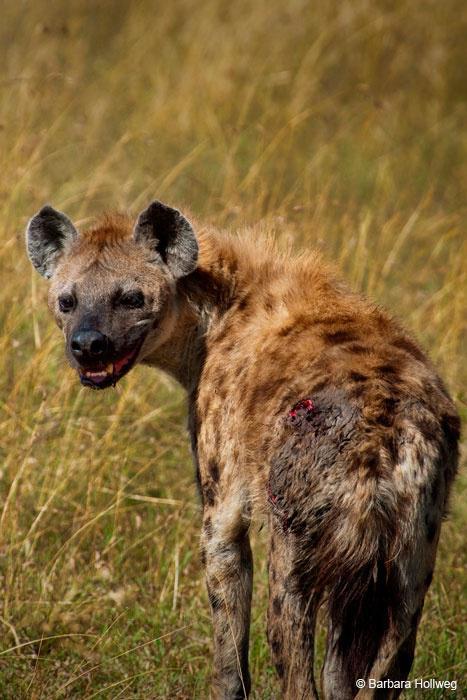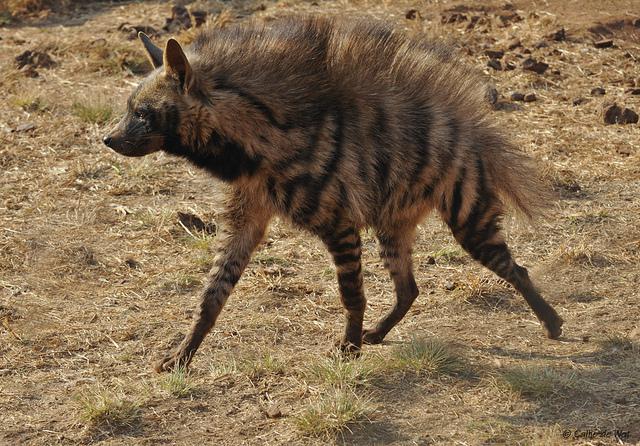The first image is the image on the left, the second image is the image on the right. Evaluate the accuracy of this statement regarding the images: "There is at least one animal carrying another animal or part of another animal.". Is it true? Answer yes or no. No. The first image is the image on the left, the second image is the image on the right. Examine the images to the left and right. Is the description "There is a hyena carrying prey in its mouth." accurate? Answer yes or no. No. 